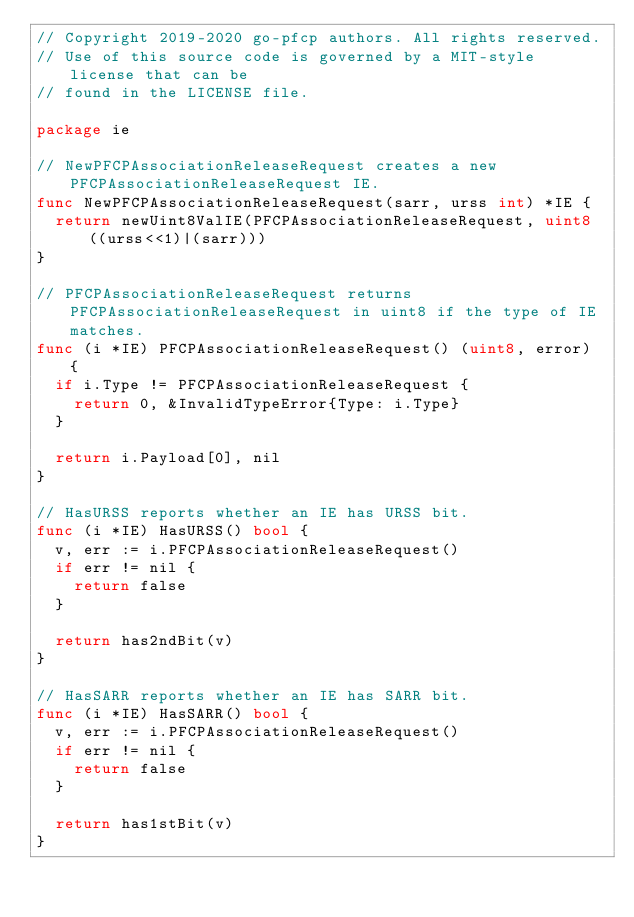Convert code to text. <code><loc_0><loc_0><loc_500><loc_500><_Go_>// Copyright 2019-2020 go-pfcp authors. All rights reserved.
// Use of this source code is governed by a MIT-style license that can be
// found in the LICENSE file.

package ie

// NewPFCPAssociationReleaseRequest creates a new PFCPAssociationReleaseRequest IE.
func NewPFCPAssociationReleaseRequest(sarr, urss int) *IE {
	return newUint8ValIE(PFCPAssociationReleaseRequest, uint8((urss<<1)|(sarr)))
}

// PFCPAssociationReleaseRequest returns PFCPAssociationReleaseRequest in uint8 if the type of IE matches.
func (i *IE) PFCPAssociationReleaseRequest() (uint8, error) {
	if i.Type != PFCPAssociationReleaseRequest {
		return 0, &InvalidTypeError{Type: i.Type}
	}

	return i.Payload[0], nil
}

// HasURSS reports whether an IE has URSS bit.
func (i *IE) HasURSS() bool {
	v, err := i.PFCPAssociationReleaseRequest()
	if err != nil {
		return false
	}

	return has2ndBit(v)
}

// HasSARR reports whether an IE has SARR bit.
func (i *IE) HasSARR() bool {
	v, err := i.PFCPAssociationReleaseRequest()
	if err != nil {
		return false
	}

	return has1stBit(v)
}
</code> 